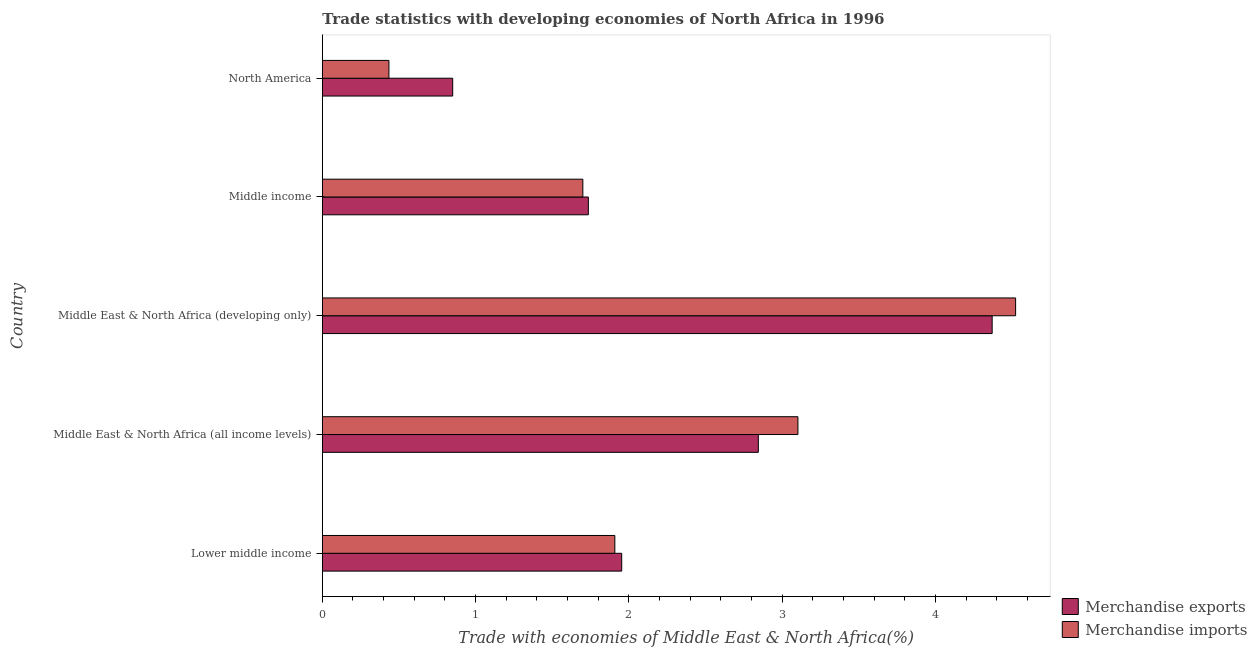Are the number of bars per tick equal to the number of legend labels?
Ensure brevity in your answer.  Yes. How many bars are there on the 4th tick from the top?
Offer a terse response. 2. What is the label of the 1st group of bars from the top?
Give a very brief answer. North America. What is the merchandise imports in North America?
Keep it short and to the point. 0.43. Across all countries, what is the maximum merchandise exports?
Ensure brevity in your answer.  4.37. Across all countries, what is the minimum merchandise imports?
Make the answer very short. 0.43. In which country was the merchandise exports maximum?
Give a very brief answer. Middle East & North Africa (developing only). In which country was the merchandise exports minimum?
Ensure brevity in your answer.  North America. What is the total merchandise exports in the graph?
Offer a very short reply. 11.76. What is the difference between the merchandise imports in Middle income and that in North America?
Offer a very short reply. 1.26. What is the difference between the merchandise imports in North America and the merchandise exports in Middle East & North Africa (all income levels)?
Give a very brief answer. -2.41. What is the average merchandise imports per country?
Your answer should be compact. 2.33. What is the difference between the merchandise imports and merchandise exports in Middle income?
Provide a succinct answer. -0.04. What is the ratio of the merchandise imports in Lower middle income to that in North America?
Keep it short and to the point. 4.39. Is the merchandise imports in Lower middle income less than that in Middle East & North Africa (all income levels)?
Your response must be concise. Yes. Is the difference between the merchandise imports in Middle East & North Africa (all income levels) and Middle income greater than the difference between the merchandise exports in Middle East & North Africa (all income levels) and Middle income?
Give a very brief answer. Yes. What is the difference between the highest and the second highest merchandise exports?
Provide a short and direct response. 1.53. What is the difference between the highest and the lowest merchandise exports?
Provide a short and direct response. 3.52. In how many countries, is the merchandise exports greater than the average merchandise exports taken over all countries?
Your answer should be very brief. 2. What does the 1st bar from the top in Middle East & North Africa (all income levels) represents?
Provide a succinct answer. Merchandise imports. What does the 2nd bar from the bottom in Middle East & North Africa (all income levels) represents?
Offer a very short reply. Merchandise imports. How many bars are there?
Offer a terse response. 10. Does the graph contain grids?
Make the answer very short. No. Where does the legend appear in the graph?
Offer a very short reply. Bottom right. How many legend labels are there?
Make the answer very short. 2. How are the legend labels stacked?
Provide a short and direct response. Vertical. What is the title of the graph?
Offer a terse response. Trade statistics with developing economies of North Africa in 1996. What is the label or title of the X-axis?
Your answer should be very brief. Trade with economies of Middle East & North Africa(%). What is the label or title of the Y-axis?
Offer a terse response. Country. What is the Trade with economies of Middle East & North Africa(%) in Merchandise exports in Lower middle income?
Make the answer very short. 1.95. What is the Trade with economies of Middle East & North Africa(%) of Merchandise imports in Lower middle income?
Your answer should be compact. 1.91. What is the Trade with economies of Middle East & North Africa(%) in Merchandise exports in Middle East & North Africa (all income levels)?
Provide a succinct answer. 2.84. What is the Trade with economies of Middle East & North Africa(%) of Merchandise imports in Middle East & North Africa (all income levels)?
Offer a very short reply. 3.1. What is the Trade with economies of Middle East & North Africa(%) in Merchandise exports in Middle East & North Africa (developing only)?
Ensure brevity in your answer.  4.37. What is the Trade with economies of Middle East & North Africa(%) of Merchandise imports in Middle East & North Africa (developing only)?
Provide a succinct answer. 4.52. What is the Trade with economies of Middle East & North Africa(%) in Merchandise exports in Middle income?
Ensure brevity in your answer.  1.74. What is the Trade with economies of Middle East & North Africa(%) of Merchandise imports in Middle income?
Make the answer very short. 1.7. What is the Trade with economies of Middle East & North Africa(%) of Merchandise exports in North America?
Give a very brief answer. 0.85. What is the Trade with economies of Middle East & North Africa(%) of Merchandise imports in North America?
Keep it short and to the point. 0.43. Across all countries, what is the maximum Trade with economies of Middle East & North Africa(%) in Merchandise exports?
Offer a terse response. 4.37. Across all countries, what is the maximum Trade with economies of Middle East & North Africa(%) in Merchandise imports?
Provide a short and direct response. 4.52. Across all countries, what is the minimum Trade with economies of Middle East & North Africa(%) in Merchandise exports?
Give a very brief answer. 0.85. Across all countries, what is the minimum Trade with economies of Middle East & North Africa(%) of Merchandise imports?
Make the answer very short. 0.43. What is the total Trade with economies of Middle East & North Africa(%) in Merchandise exports in the graph?
Make the answer very short. 11.76. What is the total Trade with economies of Middle East & North Africa(%) of Merchandise imports in the graph?
Provide a short and direct response. 11.67. What is the difference between the Trade with economies of Middle East & North Africa(%) of Merchandise exports in Lower middle income and that in Middle East & North Africa (all income levels)?
Give a very brief answer. -0.89. What is the difference between the Trade with economies of Middle East & North Africa(%) of Merchandise imports in Lower middle income and that in Middle East & North Africa (all income levels)?
Provide a succinct answer. -1.19. What is the difference between the Trade with economies of Middle East & North Africa(%) of Merchandise exports in Lower middle income and that in Middle East & North Africa (developing only)?
Your response must be concise. -2.42. What is the difference between the Trade with economies of Middle East & North Africa(%) of Merchandise imports in Lower middle income and that in Middle East & North Africa (developing only)?
Ensure brevity in your answer.  -2.62. What is the difference between the Trade with economies of Middle East & North Africa(%) in Merchandise exports in Lower middle income and that in Middle income?
Give a very brief answer. 0.22. What is the difference between the Trade with economies of Middle East & North Africa(%) in Merchandise imports in Lower middle income and that in Middle income?
Your answer should be very brief. 0.21. What is the difference between the Trade with economies of Middle East & North Africa(%) of Merchandise exports in Lower middle income and that in North America?
Offer a very short reply. 1.1. What is the difference between the Trade with economies of Middle East & North Africa(%) of Merchandise imports in Lower middle income and that in North America?
Provide a succinct answer. 1.47. What is the difference between the Trade with economies of Middle East & North Africa(%) in Merchandise exports in Middle East & North Africa (all income levels) and that in Middle East & North Africa (developing only)?
Your answer should be compact. -1.53. What is the difference between the Trade with economies of Middle East & North Africa(%) in Merchandise imports in Middle East & North Africa (all income levels) and that in Middle East & North Africa (developing only)?
Your answer should be very brief. -1.42. What is the difference between the Trade with economies of Middle East & North Africa(%) in Merchandise exports in Middle East & North Africa (all income levels) and that in Middle income?
Give a very brief answer. 1.11. What is the difference between the Trade with economies of Middle East & North Africa(%) in Merchandise imports in Middle East & North Africa (all income levels) and that in Middle income?
Your response must be concise. 1.4. What is the difference between the Trade with economies of Middle East & North Africa(%) of Merchandise exports in Middle East & North Africa (all income levels) and that in North America?
Offer a very short reply. 1.99. What is the difference between the Trade with economies of Middle East & North Africa(%) of Merchandise imports in Middle East & North Africa (all income levels) and that in North America?
Keep it short and to the point. 2.67. What is the difference between the Trade with economies of Middle East & North Africa(%) of Merchandise exports in Middle East & North Africa (developing only) and that in Middle income?
Make the answer very short. 2.63. What is the difference between the Trade with economies of Middle East & North Africa(%) of Merchandise imports in Middle East & North Africa (developing only) and that in Middle income?
Provide a short and direct response. 2.82. What is the difference between the Trade with economies of Middle East & North Africa(%) in Merchandise exports in Middle East & North Africa (developing only) and that in North America?
Your answer should be very brief. 3.52. What is the difference between the Trade with economies of Middle East & North Africa(%) in Merchandise imports in Middle East & North Africa (developing only) and that in North America?
Keep it short and to the point. 4.09. What is the difference between the Trade with economies of Middle East & North Africa(%) of Merchandise exports in Middle income and that in North America?
Keep it short and to the point. 0.89. What is the difference between the Trade with economies of Middle East & North Africa(%) of Merchandise imports in Middle income and that in North America?
Keep it short and to the point. 1.27. What is the difference between the Trade with economies of Middle East & North Africa(%) of Merchandise exports in Lower middle income and the Trade with economies of Middle East & North Africa(%) of Merchandise imports in Middle East & North Africa (all income levels)?
Provide a succinct answer. -1.15. What is the difference between the Trade with economies of Middle East & North Africa(%) of Merchandise exports in Lower middle income and the Trade with economies of Middle East & North Africa(%) of Merchandise imports in Middle East & North Africa (developing only)?
Provide a succinct answer. -2.57. What is the difference between the Trade with economies of Middle East & North Africa(%) of Merchandise exports in Lower middle income and the Trade with economies of Middle East & North Africa(%) of Merchandise imports in Middle income?
Offer a very short reply. 0.25. What is the difference between the Trade with economies of Middle East & North Africa(%) in Merchandise exports in Lower middle income and the Trade with economies of Middle East & North Africa(%) in Merchandise imports in North America?
Offer a very short reply. 1.52. What is the difference between the Trade with economies of Middle East & North Africa(%) of Merchandise exports in Middle East & North Africa (all income levels) and the Trade with economies of Middle East & North Africa(%) of Merchandise imports in Middle East & North Africa (developing only)?
Give a very brief answer. -1.68. What is the difference between the Trade with economies of Middle East & North Africa(%) in Merchandise exports in Middle East & North Africa (all income levels) and the Trade with economies of Middle East & North Africa(%) in Merchandise imports in Middle income?
Your answer should be very brief. 1.15. What is the difference between the Trade with economies of Middle East & North Africa(%) in Merchandise exports in Middle East & North Africa (all income levels) and the Trade with economies of Middle East & North Africa(%) in Merchandise imports in North America?
Ensure brevity in your answer.  2.41. What is the difference between the Trade with economies of Middle East & North Africa(%) of Merchandise exports in Middle East & North Africa (developing only) and the Trade with economies of Middle East & North Africa(%) of Merchandise imports in Middle income?
Offer a very short reply. 2.67. What is the difference between the Trade with economies of Middle East & North Africa(%) of Merchandise exports in Middle East & North Africa (developing only) and the Trade with economies of Middle East & North Africa(%) of Merchandise imports in North America?
Your response must be concise. 3.94. What is the difference between the Trade with economies of Middle East & North Africa(%) of Merchandise exports in Middle income and the Trade with economies of Middle East & North Africa(%) of Merchandise imports in North America?
Provide a short and direct response. 1.3. What is the average Trade with economies of Middle East & North Africa(%) of Merchandise exports per country?
Your response must be concise. 2.35. What is the average Trade with economies of Middle East & North Africa(%) of Merchandise imports per country?
Offer a terse response. 2.33. What is the difference between the Trade with economies of Middle East & North Africa(%) of Merchandise exports and Trade with economies of Middle East & North Africa(%) of Merchandise imports in Lower middle income?
Give a very brief answer. 0.04. What is the difference between the Trade with economies of Middle East & North Africa(%) in Merchandise exports and Trade with economies of Middle East & North Africa(%) in Merchandise imports in Middle East & North Africa (all income levels)?
Offer a very short reply. -0.26. What is the difference between the Trade with economies of Middle East & North Africa(%) in Merchandise exports and Trade with economies of Middle East & North Africa(%) in Merchandise imports in Middle East & North Africa (developing only)?
Provide a short and direct response. -0.15. What is the difference between the Trade with economies of Middle East & North Africa(%) of Merchandise exports and Trade with economies of Middle East & North Africa(%) of Merchandise imports in Middle income?
Provide a short and direct response. 0.04. What is the difference between the Trade with economies of Middle East & North Africa(%) in Merchandise exports and Trade with economies of Middle East & North Africa(%) in Merchandise imports in North America?
Your answer should be very brief. 0.42. What is the ratio of the Trade with economies of Middle East & North Africa(%) in Merchandise exports in Lower middle income to that in Middle East & North Africa (all income levels)?
Offer a terse response. 0.69. What is the ratio of the Trade with economies of Middle East & North Africa(%) in Merchandise imports in Lower middle income to that in Middle East & North Africa (all income levels)?
Provide a succinct answer. 0.61. What is the ratio of the Trade with economies of Middle East & North Africa(%) of Merchandise exports in Lower middle income to that in Middle East & North Africa (developing only)?
Ensure brevity in your answer.  0.45. What is the ratio of the Trade with economies of Middle East & North Africa(%) in Merchandise imports in Lower middle income to that in Middle East & North Africa (developing only)?
Keep it short and to the point. 0.42. What is the ratio of the Trade with economies of Middle East & North Africa(%) of Merchandise exports in Lower middle income to that in Middle income?
Your answer should be compact. 1.13. What is the ratio of the Trade with economies of Middle East & North Africa(%) of Merchandise imports in Lower middle income to that in Middle income?
Keep it short and to the point. 1.12. What is the ratio of the Trade with economies of Middle East & North Africa(%) in Merchandise exports in Lower middle income to that in North America?
Provide a short and direct response. 2.3. What is the ratio of the Trade with economies of Middle East & North Africa(%) of Merchandise imports in Lower middle income to that in North America?
Offer a very short reply. 4.39. What is the ratio of the Trade with economies of Middle East & North Africa(%) in Merchandise exports in Middle East & North Africa (all income levels) to that in Middle East & North Africa (developing only)?
Keep it short and to the point. 0.65. What is the ratio of the Trade with economies of Middle East & North Africa(%) of Merchandise imports in Middle East & North Africa (all income levels) to that in Middle East & North Africa (developing only)?
Your answer should be compact. 0.69. What is the ratio of the Trade with economies of Middle East & North Africa(%) of Merchandise exports in Middle East & North Africa (all income levels) to that in Middle income?
Make the answer very short. 1.64. What is the ratio of the Trade with economies of Middle East & North Africa(%) of Merchandise imports in Middle East & North Africa (all income levels) to that in Middle income?
Give a very brief answer. 1.83. What is the ratio of the Trade with economies of Middle East & North Africa(%) in Merchandise exports in Middle East & North Africa (all income levels) to that in North America?
Your answer should be very brief. 3.34. What is the ratio of the Trade with economies of Middle East & North Africa(%) of Merchandise imports in Middle East & North Africa (all income levels) to that in North America?
Provide a succinct answer. 7.14. What is the ratio of the Trade with economies of Middle East & North Africa(%) of Merchandise exports in Middle East & North Africa (developing only) to that in Middle income?
Keep it short and to the point. 2.52. What is the ratio of the Trade with economies of Middle East & North Africa(%) in Merchandise imports in Middle East & North Africa (developing only) to that in Middle income?
Your response must be concise. 2.66. What is the ratio of the Trade with economies of Middle East & North Africa(%) in Merchandise exports in Middle East & North Africa (developing only) to that in North America?
Keep it short and to the point. 5.14. What is the ratio of the Trade with economies of Middle East & North Africa(%) of Merchandise imports in Middle East & North Africa (developing only) to that in North America?
Offer a very short reply. 10.41. What is the ratio of the Trade with economies of Middle East & North Africa(%) in Merchandise exports in Middle income to that in North America?
Ensure brevity in your answer.  2.04. What is the ratio of the Trade with economies of Middle East & North Africa(%) of Merchandise imports in Middle income to that in North America?
Offer a terse response. 3.91. What is the difference between the highest and the second highest Trade with economies of Middle East & North Africa(%) in Merchandise exports?
Keep it short and to the point. 1.53. What is the difference between the highest and the second highest Trade with economies of Middle East & North Africa(%) of Merchandise imports?
Your answer should be very brief. 1.42. What is the difference between the highest and the lowest Trade with economies of Middle East & North Africa(%) in Merchandise exports?
Your answer should be very brief. 3.52. What is the difference between the highest and the lowest Trade with economies of Middle East & North Africa(%) of Merchandise imports?
Offer a very short reply. 4.09. 